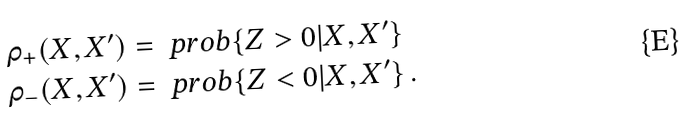Convert formula to latex. <formula><loc_0><loc_0><loc_500><loc_500>\rho _ { + } ( X , X ^ { \prime } ) & = \ p r o b \{ Z > 0 | X , X ^ { \prime } \} \\ \rho _ { - } ( X , X ^ { \prime } ) & = \ p r o b \{ Z < 0 | X , X ^ { \prime } \} \, .</formula> 